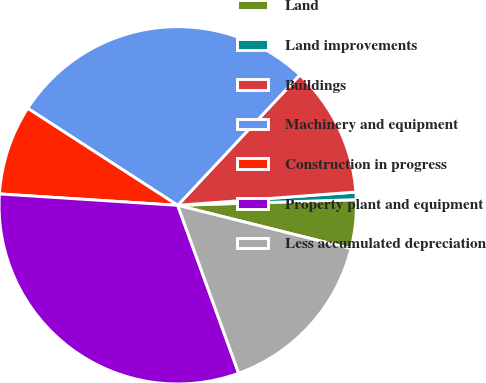Convert chart to OTSL. <chart><loc_0><loc_0><loc_500><loc_500><pie_chart><fcel>Land<fcel>Land improvements<fcel>Buildings<fcel>Machinery and equipment<fcel>Construction in progress<fcel>Property plant and equipment<fcel>Less accumulated depreciation<nl><fcel>4.4%<fcel>0.68%<fcel>11.84%<fcel>27.84%<fcel>8.12%<fcel>31.56%<fcel>15.56%<nl></chart> 